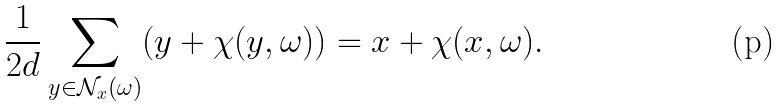<formula> <loc_0><loc_0><loc_500><loc_500>\frac { 1 } { 2 d } \sum _ { y \in \mathcal { N } _ { x } ( \omega ) } ( y + \chi ( y , \omega ) ) = x + \chi ( x , \omega ) .</formula> 